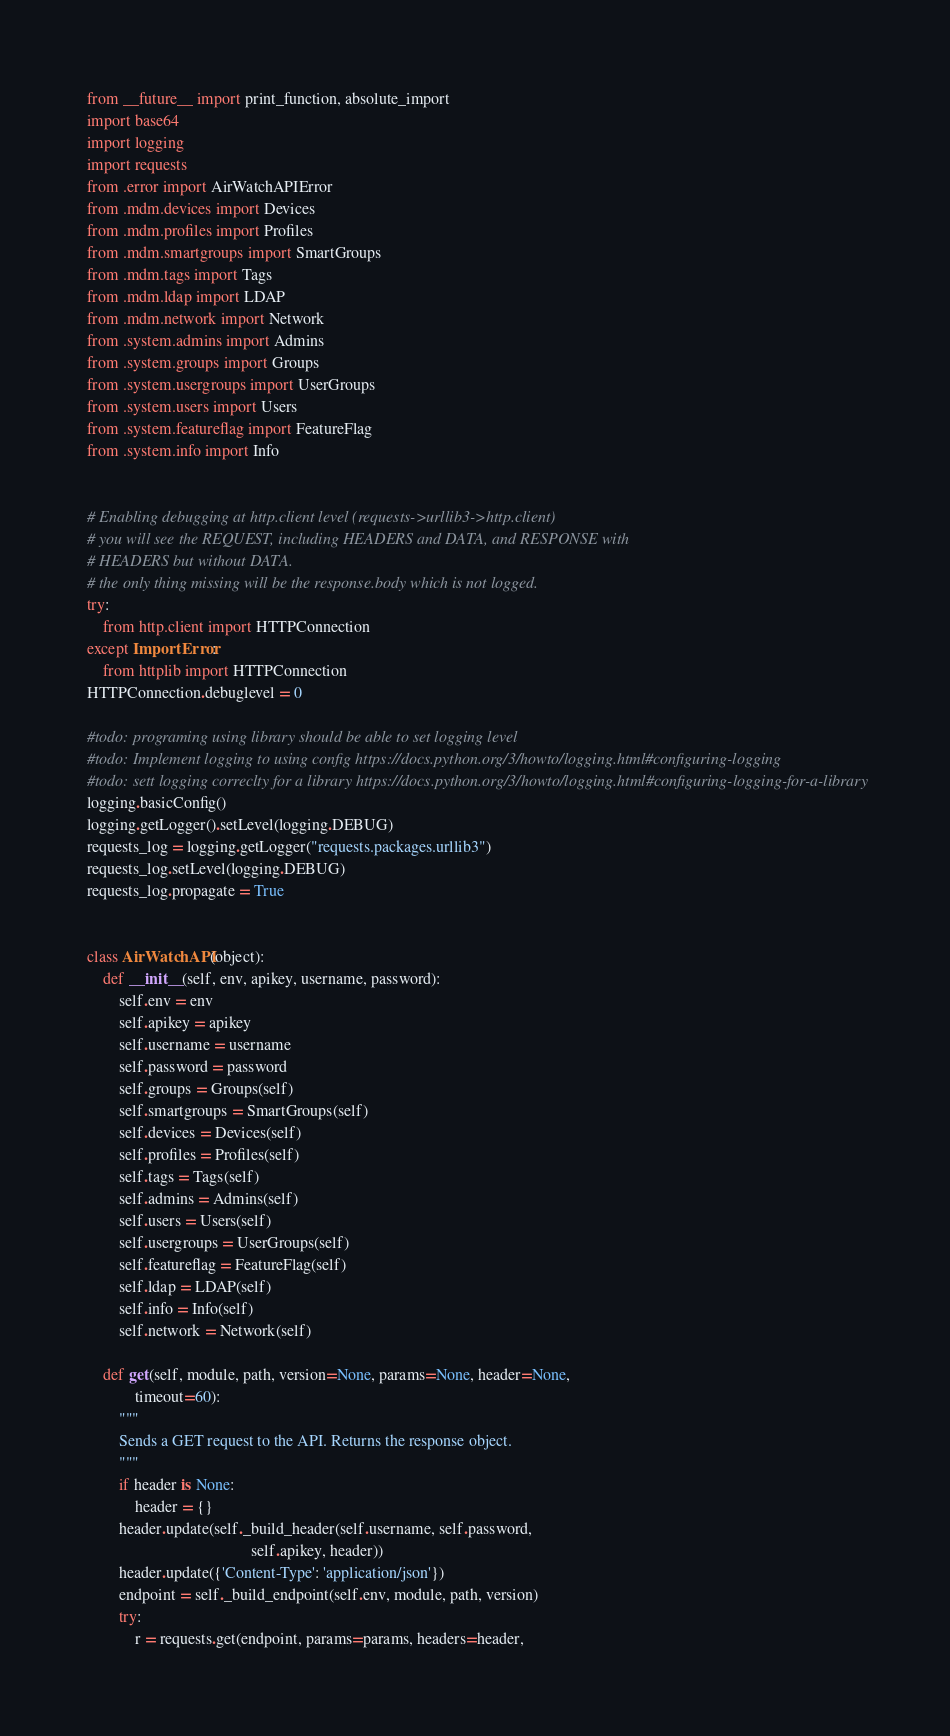Convert code to text. <code><loc_0><loc_0><loc_500><loc_500><_Python_>from __future__ import print_function, absolute_import
import base64
import logging
import requests
from .error import AirWatchAPIError
from .mdm.devices import Devices
from .mdm.profiles import Profiles
from .mdm.smartgroups import SmartGroups
from .mdm.tags import Tags
from .mdm.ldap import LDAP
from .mdm.network import Network
from .system.admins import Admins
from .system.groups import Groups
from .system.usergroups import UserGroups
from .system.users import Users
from .system.featureflag import FeatureFlag
from .system.info import Info


# Enabling debugging at http.client level (requests->urllib3->http.client)
# you will see the REQUEST, including HEADERS and DATA, and RESPONSE with
# HEADERS but without DATA.
# the only thing missing will be the response.body which is not logged.
try:
    from http.client import HTTPConnection
except ImportError:
    from httplib import HTTPConnection
HTTPConnection.debuglevel = 0

#todo: programing using library should be able to set logging level
#todo: Implement logging to using config https://docs.python.org/3/howto/logging.html#configuring-logging
#todo: sett logging correclty for a library https://docs.python.org/3/howto/logging.html#configuring-logging-for-a-library
logging.basicConfig()
logging.getLogger().setLevel(logging.DEBUG)
requests_log = logging.getLogger("requests.packages.urllib3")
requests_log.setLevel(logging.DEBUG)
requests_log.propagate = True


class AirWatchAPI(object):
    def __init__(self, env, apikey, username, password):
        self.env = env
        self.apikey = apikey
        self.username = username
        self.password = password
        self.groups = Groups(self)
        self.smartgroups = SmartGroups(self)
        self.devices = Devices(self)
        self.profiles = Profiles(self)
        self.tags = Tags(self)
        self.admins = Admins(self)
        self.users = Users(self)
        self.usergroups = UserGroups(self)
        self.featureflag = FeatureFlag(self)
        self.ldap = LDAP(self)
        self.info = Info(self)
        self.network = Network(self)

    def get(self, module, path, version=None, params=None, header=None,
            timeout=60):
        """
        Sends a GET request to the API. Returns the response object.
        """
        if header is None:
            header = {}
        header.update(self._build_header(self.username, self.password,
                                         self.apikey, header))
        header.update({'Content-Type': 'application/json'})
        endpoint = self._build_endpoint(self.env, module, path, version)
        try:
            r = requests.get(endpoint, params=params, headers=header,</code> 